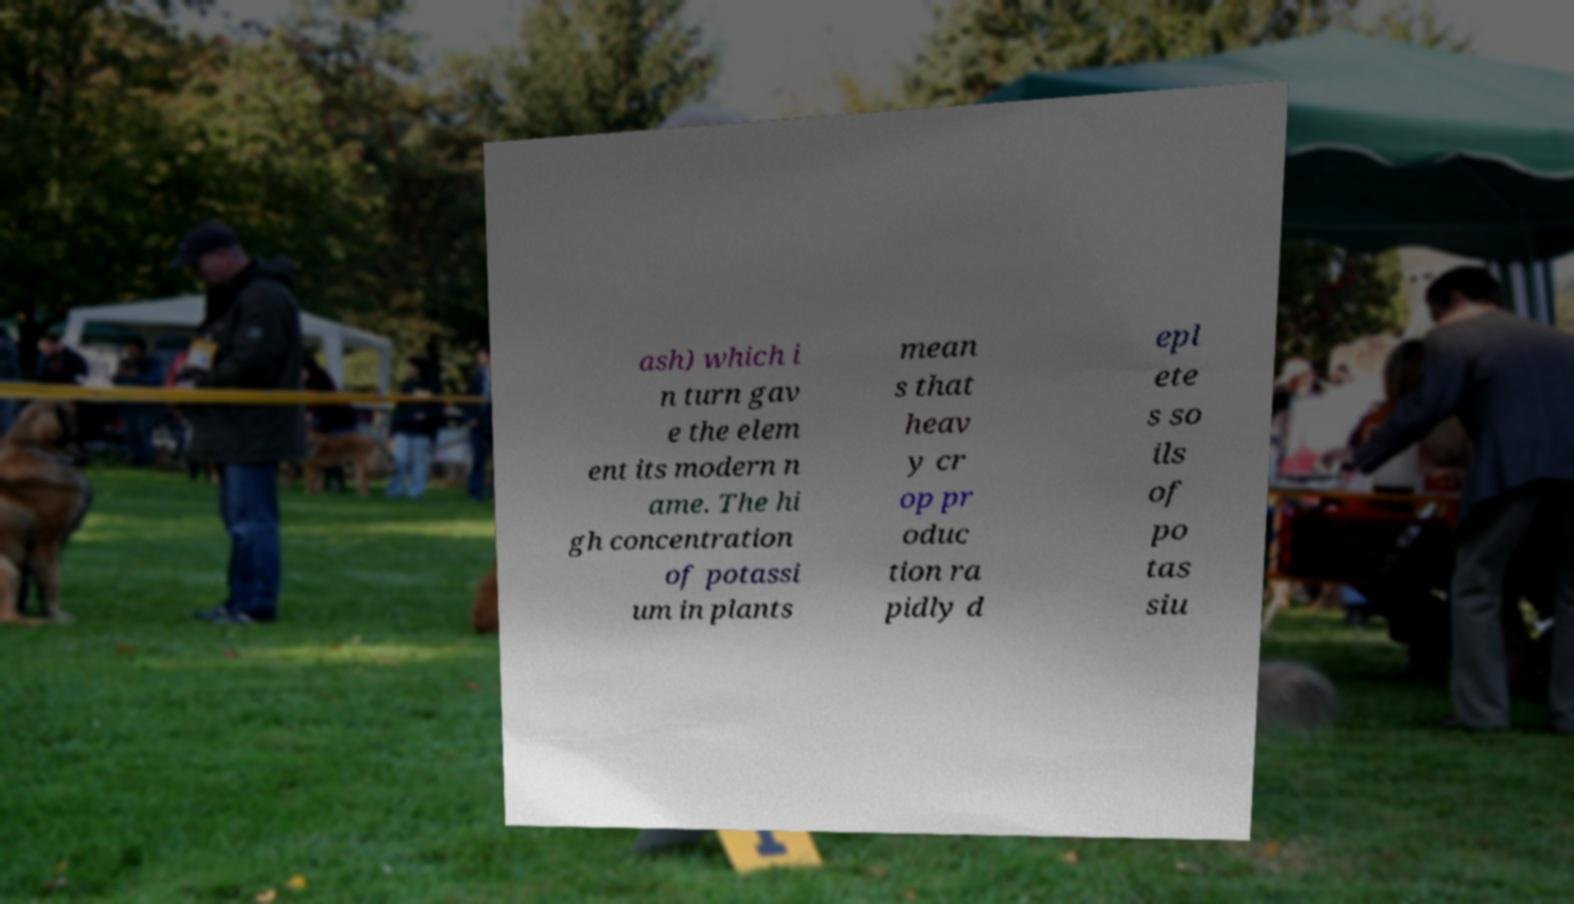There's text embedded in this image that I need extracted. Can you transcribe it verbatim? ash) which i n turn gav e the elem ent its modern n ame. The hi gh concentration of potassi um in plants mean s that heav y cr op pr oduc tion ra pidly d epl ete s so ils of po tas siu 